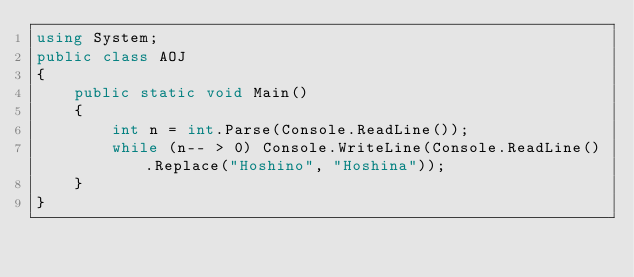Convert code to text. <code><loc_0><loc_0><loc_500><loc_500><_C#_>using System;
public class AOJ
{
    public static void Main()
    {
        int n = int.Parse(Console.ReadLine());
        while (n-- > 0) Console.WriteLine(Console.ReadLine().Replace("Hoshino", "Hoshina"));
    }
}
</code> 